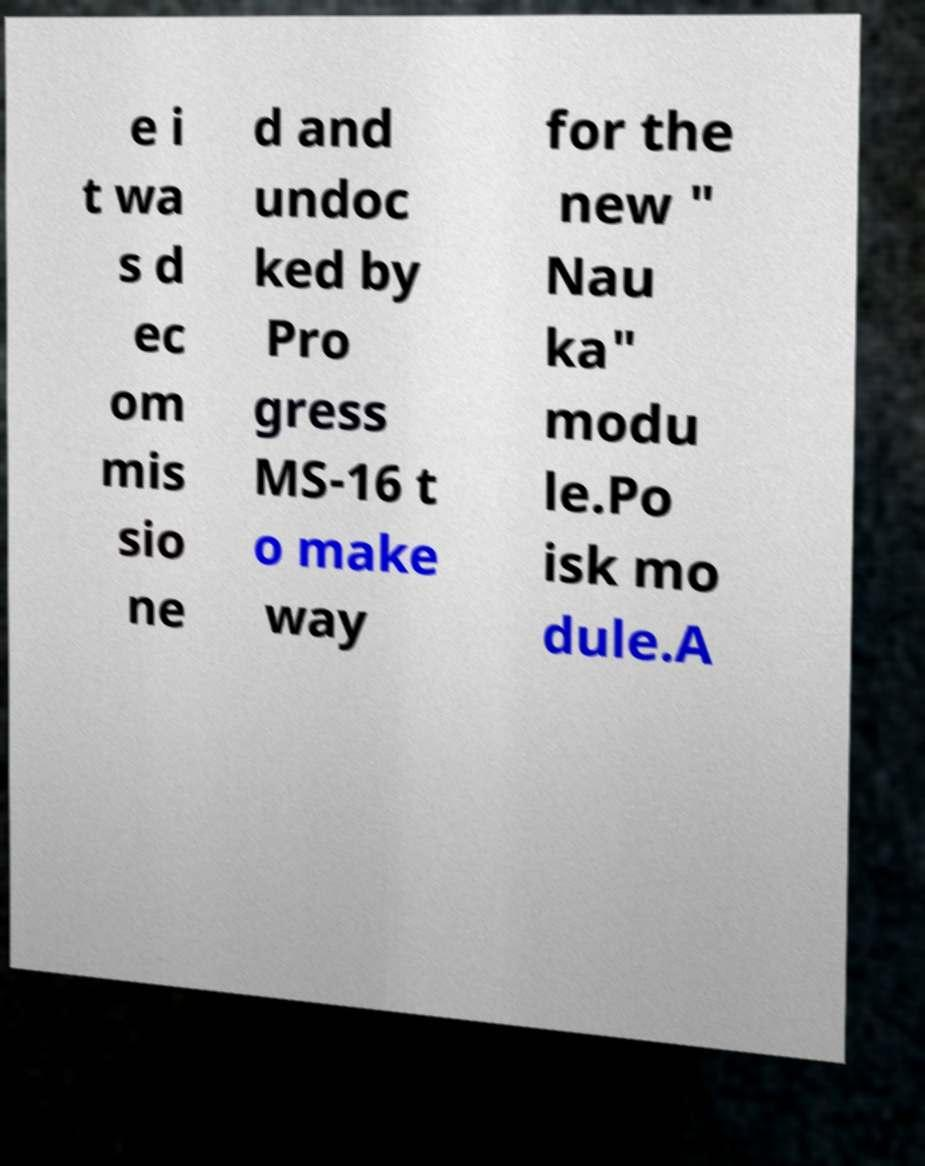Can you accurately transcribe the text from the provided image for me? e i t wa s d ec om mis sio ne d and undoc ked by Pro gress MS-16 t o make way for the new " Nau ka" modu le.Po isk mo dule.A 